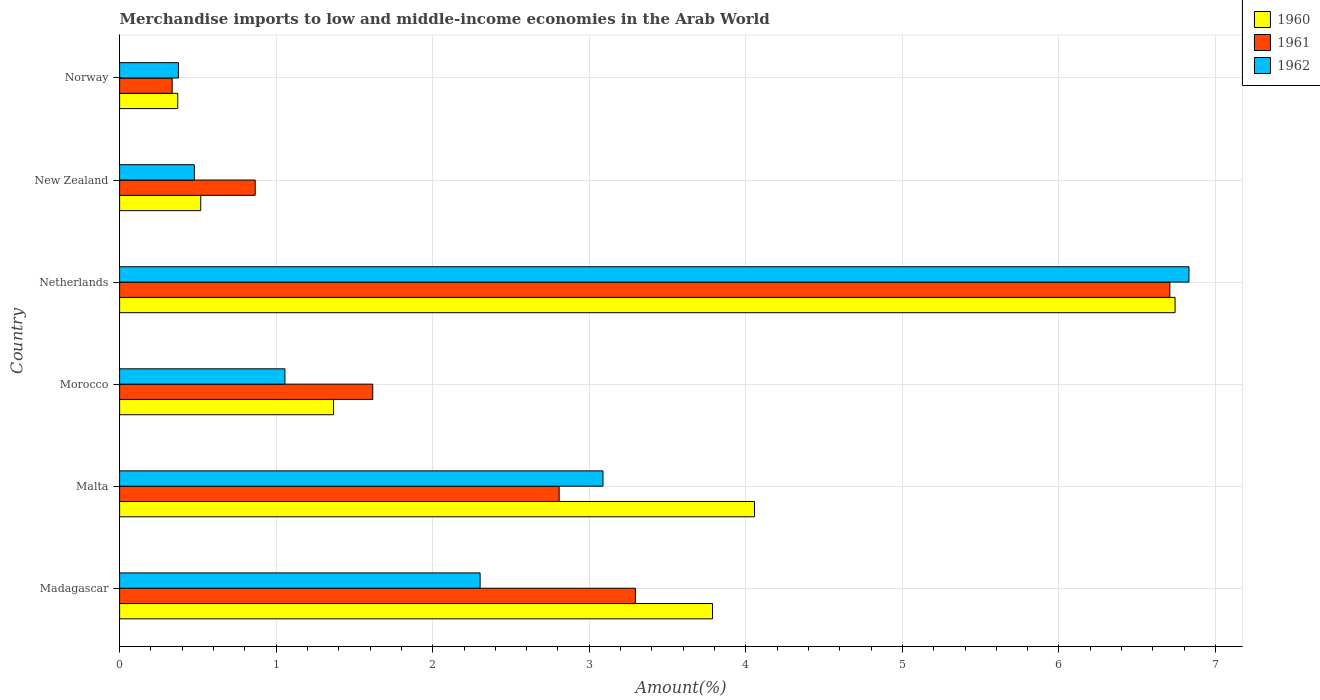Are the number of bars per tick equal to the number of legend labels?
Keep it short and to the point. Yes. How many bars are there on the 2nd tick from the top?
Provide a succinct answer. 3. What is the label of the 1st group of bars from the top?
Ensure brevity in your answer.  Norway. What is the percentage of amount earned from merchandise imports in 1961 in Morocco?
Keep it short and to the point. 1.62. Across all countries, what is the maximum percentage of amount earned from merchandise imports in 1960?
Your answer should be very brief. 6.74. Across all countries, what is the minimum percentage of amount earned from merchandise imports in 1960?
Offer a very short reply. 0.37. What is the total percentage of amount earned from merchandise imports in 1960 in the graph?
Your response must be concise. 16.84. What is the difference between the percentage of amount earned from merchandise imports in 1962 in Netherlands and that in New Zealand?
Your answer should be compact. 6.35. What is the difference between the percentage of amount earned from merchandise imports in 1962 in New Zealand and the percentage of amount earned from merchandise imports in 1960 in Madagascar?
Ensure brevity in your answer.  -3.31. What is the average percentage of amount earned from merchandise imports in 1961 per country?
Provide a succinct answer. 2.6. What is the difference between the percentage of amount earned from merchandise imports in 1961 and percentage of amount earned from merchandise imports in 1960 in Malta?
Offer a very short reply. -1.25. In how many countries, is the percentage of amount earned from merchandise imports in 1962 greater than 5.4 %?
Ensure brevity in your answer.  1. What is the ratio of the percentage of amount earned from merchandise imports in 1960 in Malta to that in Norway?
Keep it short and to the point. 10.92. Is the percentage of amount earned from merchandise imports in 1962 in Madagascar less than that in Norway?
Give a very brief answer. No. Is the difference between the percentage of amount earned from merchandise imports in 1961 in Madagascar and Netherlands greater than the difference between the percentage of amount earned from merchandise imports in 1960 in Madagascar and Netherlands?
Your answer should be very brief. No. What is the difference between the highest and the second highest percentage of amount earned from merchandise imports in 1961?
Keep it short and to the point. 3.41. What is the difference between the highest and the lowest percentage of amount earned from merchandise imports in 1960?
Make the answer very short. 6.37. In how many countries, is the percentage of amount earned from merchandise imports in 1962 greater than the average percentage of amount earned from merchandise imports in 1962 taken over all countries?
Keep it short and to the point. 2. What does the 2nd bar from the bottom in Malta represents?
Offer a very short reply. 1961. Is it the case that in every country, the sum of the percentage of amount earned from merchandise imports in 1962 and percentage of amount earned from merchandise imports in 1961 is greater than the percentage of amount earned from merchandise imports in 1960?
Provide a succinct answer. Yes. Does the graph contain any zero values?
Your response must be concise. No. How are the legend labels stacked?
Your answer should be very brief. Vertical. What is the title of the graph?
Provide a short and direct response. Merchandise imports to low and middle-income economies in the Arab World. What is the label or title of the X-axis?
Provide a succinct answer. Amount(%). What is the Amount(%) of 1960 in Madagascar?
Offer a very short reply. 3.79. What is the Amount(%) in 1961 in Madagascar?
Give a very brief answer. 3.29. What is the Amount(%) in 1962 in Madagascar?
Your answer should be very brief. 2.3. What is the Amount(%) in 1960 in Malta?
Give a very brief answer. 4.06. What is the Amount(%) in 1961 in Malta?
Keep it short and to the point. 2.81. What is the Amount(%) of 1962 in Malta?
Your answer should be very brief. 3.09. What is the Amount(%) of 1960 in Morocco?
Make the answer very short. 1.37. What is the Amount(%) in 1961 in Morocco?
Offer a terse response. 1.62. What is the Amount(%) in 1962 in Morocco?
Give a very brief answer. 1.06. What is the Amount(%) of 1960 in Netherlands?
Provide a short and direct response. 6.74. What is the Amount(%) of 1961 in Netherlands?
Give a very brief answer. 6.71. What is the Amount(%) of 1962 in Netherlands?
Keep it short and to the point. 6.83. What is the Amount(%) of 1960 in New Zealand?
Keep it short and to the point. 0.52. What is the Amount(%) in 1961 in New Zealand?
Offer a terse response. 0.87. What is the Amount(%) in 1962 in New Zealand?
Offer a terse response. 0.48. What is the Amount(%) in 1960 in Norway?
Ensure brevity in your answer.  0.37. What is the Amount(%) in 1961 in Norway?
Your response must be concise. 0.34. What is the Amount(%) of 1962 in Norway?
Your answer should be very brief. 0.38. Across all countries, what is the maximum Amount(%) of 1960?
Keep it short and to the point. 6.74. Across all countries, what is the maximum Amount(%) in 1961?
Keep it short and to the point. 6.71. Across all countries, what is the maximum Amount(%) of 1962?
Provide a short and direct response. 6.83. Across all countries, what is the minimum Amount(%) of 1960?
Your answer should be compact. 0.37. Across all countries, what is the minimum Amount(%) of 1961?
Provide a short and direct response. 0.34. Across all countries, what is the minimum Amount(%) in 1962?
Your response must be concise. 0.38. What is the total Amount(%) in 1960 in the graph?
Offer a terse response. 16.84. What is the total Amount(%) in 1961 in the graph?
Your answer should be compact. 15.63. What is the total Amount(%) in 1962 in the graph?
Provide a short and direct response. 14.13. What is the difference between the Amount(%) in 1960 in Madagascar and that in Malta?
Keep it short and to the point. -0.27. What is the difference between the Amount(%) of 1961 in Madagascar and that in Malta?
Offer a very short reply. 0.49. What is the difference between the Amount(%) in 1962 in Madagascar and that in Malta?
Provide a succinct answer. -0.79. What is the difference between the Amount(%) of 1960 in Madagascar and that in Morocco?
Provide a succinct answer. 2.42. What is the difference between the Amount(%) in 1961 in Madagascar and that in Morocco?
Make the answer very short. 1.68. What is the difference between the Amount(%) of 1962 in Madagascar and that in Morocco?
Provide a succinct answer. 1.25. What is the difference between the Amount(%) of 1960 in Madagascar and that in Netherlands?
Give a very brief answer. -2.95. What is the difference between the Amount(%) in 1961 in Madagascar and that in Netherlands?
Give a very brief answer. -3.41. What is the difference between the Amount(%) of 1962 in Madagascar and that in Netherlands?
Offer a very short reply. -4.53. What is the difference between the Amount(%) of 1960 in Madagascar and that in New Zealand?
Give a very brief answer. 3.27. What is the difference between the Amount(%) of 1961 in Madagascar and that in New Zealand?
Provide a succinct answer. 2.43. What is the difference between the Amount(%) in 1962 in Madagascar and that in New Zealand?
Offer a very short reply. 1.83. What is the difference between the Amount(%) in 1960 in Madagascar and that in Norway?
Provide a succinct answer. 3.42. What is the difference between the Amount(%) of 1961 in Madagascar and that in Norway?
Your answer should be compact. 2.96. What is the difference between the Amount(%) in 1962 in Madagascar and that in Norway?
Provide a succinct answer. 1.93. What is the difference between the Amount(%) of 1960 in Malta and that in Morocco?
Your response must be concise. 2.69. What is the difference between the Amount(%) in 1961 in Malta and that in Morocco?
Keep it short and to the point. 1.19. What is the difference between the Amount(%) of 1962 in Malta and that in Morocco?
Your answer should be very brief. 2.03. What is the difference between the Amount(%) of 1960 in Malta and that in Netherlands?
Ensure brevity in your answer.  -2.69. What is the difference between the Amount(%) in 1961 in Malta and that in Netherlands?
Offer a very short reply. -3.9. What is the difference between the Amount(%) of 1962 in Malta and that in Netherlands?
Give a very brief answer. -3.74. What is the difference between the Amount(%) of 1960 in Malta and that in New Zealand?
Make the answer very short. 3.54. What is the difference between the Amount(%) in 1961 in Malta and that in New Zealand?
Provide a short and direct response. 1.94. What is the difference between the Amount(%) of 1962 in Malta and that in New Zealand?
Provide a succinct answer. 2.61. What is the difference between the Amount(%) in 1960 in Malta and that in Norway?
Your response must be concise. 3.68. What is the difference between the Amount(%) of 1961 in Malta and that in Norway?
Offer a very short reply. 2.47. What is the difference between the Amount(%) in 1962 in Malta and that in Norway?
Your answer should be compact. 2.71. What is the difference between the Amount(%) of 1960 in Morocco and that in Netherlands?
Your answer should be compact. -5.38. What is the difference between the Amount(%) of 1961 in Morocco and that in Netherlands?
Give a very brief answer. -5.09. What is the difference between the Amount(%) of 1962 in Morocco and that in Netherlands?
Your answer should be very brief. -5.77. What is the difference between the Amount(%) in 1960 in Morocco and that in New Zealand?
Ensure brevity in your answer.  0.85. What is the difference between the Amount(%) in 1961 in Morocco and that in New Zealand?
Ensure brevity in your answer.  0.75. What is the difference between the Amount(%) in 1962 in Morocco and that in New Zealand?
Offer a very short reply. 0.58. What is the difference between the Amount(%) in 1960 in Morocco and that in Norway?
Your answer should be compact. 1. What is the difference between the Amount(%) in 1961 in Morocco and that in Norway?
Your response must be concise. 1.28. What is the difference between the Amount(%) of 1962 in Morocco and that in Norway?
Your answer should be compact. 0.68. What is the difference between the Amount(%) of 1960 in Netherlands and that in New Zealand?
Offer a very short reply. 6.22. What is the difference between the Amount(%) in 1961 in Netherlands and that in New Zealand?
Provide a short and direct response. 5.84. What is the difference between the Amount(%) of 1962 in Netherlands and that in New Zealand?
Provide a succinct answer. 6.35. What is the difference between the Amount(%) of 1960 in Netherlands and that in Norway?
Ensure brevity in your answer.  6.37. What is the difference between the Amount(%) in 1961 in Netherlands and that in Norway?
Your answer should be very brief. 6.37. What is the difference between the Amount(%) in 1962 in Netherlands and that in Norway?
Offer a terse response. 6.45. What is the difference between the Amount(%) in 1960 in New Zealand and that in Norway?
Keep it short and to the point. 0.15. What is the difference between the Amount(%) in 1961 in New Zealand and that in Norway?
Your answer should be compact. 0.53. What is the difference between the Amount(%) of 1962 in New Zealand and that in Norway?
Give a very brief answer. 0.1. What is the difference between the Amount(%) of 1960 in Madagascar and the Amount(%) of 1961 in Malta?
Your response must be concise. 0.98. What is the difference between the Amount(%) in 1960 in Madagascar and the Amount(%) in 1962 in Malta?
Keep it short and to the point. 0.7. What is the difference between the Amount(%) in 1961 in Madagascar and the Amount(%) in 1962 in Malta?
Provide a succinct answer. 0.21. What is the difference between the Amount(%) in 1960 in Madagascar and the Amount(%) in 1961 in Morocco?
Ensure brevity in your answer.  2.17. What is the difference between the Amount(%) of 1960 in Madagascar and the Amount(%) of 1962 in Morocco?
Ensure brevity in your answer.  2.73. What is the difference between the Amount(%) of 1961 in Madagascar and the Amount(%) of 1962 in Morocco?
Offer a terse response. 2.24. What is the difference between the Amount(%) of 1960 in Madagascar and the Amount(%) of 1961 in Netherlands?
Provide a succinct answer. -2.92. What is the difference between the Amount(%) of 1960 in Madagascar and the Amount(%) of 1962 in Netherlands?
Provide a succinct answer. -3.04. What is the difference between the Amount(%) of 1961 in Madagascar and the Amount(%) of 1962 in Netherlands?
Give a very brief answer. -3.54. What is the difference between the Amount(%) in 1960 in Madagascar and the Amount(%) in 1961 in New Zealand?
Give a very brief answer. 2.92. What is the difference between the Amount(%) in 1960 in Madagascar and the Amount(%) in 1962 in New Zealand?
Provide a short and direct response. 3.31. What is the difference between the Amount(%) of 1961 in Madagascar and the Amount(%) of 1962 in New Zealand?
Ensure brevity in your answer.  2.82. What is the difference between the Amount(%) of 1960 in Madagascar and the Amount(%) of 1961 in Norway?
Keep it short and to the point. 3.45. What is the difference between the Amount(%) of 1960 in Madagascar and the Amount(%) of 1962 in Norway?
Offer a very short reply. 3.41. What is the difference between the Amount(%) in 1961 in Madagascar and the Amount(%) in 1962 in Norway?
Offer a very short reply. 2.92. What is the difference between the Amount(%) of 1960 in Malta and the Amount(%) of 1961 in Morocco?
Your response must be concise. 2.44. What is the difference between the Amount(%) in 1960 in Malta and the Amount(%) in 1962 in Morocco?
Provide a succinct answer. 3. What is the difference between the Amount(%) in 1961 in Malta and the Amount(%) in 1962 in Morocco?
Your response must be concise. 1.75. What is the difference between the Amount(%) in 1960 in Malta and the Amount(%) in 1961 in Netherlands?
Offer a very short reply. -2.65. What is the difference between the Amount(%) in 1960 in Malta and the Amount(%) in 1962 in Netherlands?
Offer a terse response. -2.77. What is the difference between the Amount(%) in 1961 in Malta and the Amount(%) in 1962 in Netherlands?
Your answer should be very brief. -4.02. What is the difference between the Amount(%) in 1960 in Malta and the Amount(%) in 1961 in New Zealand?
Keep it short and to the point. 3.19. What is the difference between the Amount(%) in 1960 in Malta and the Amount(%) in 1962 in New Zealand?
Offer a terse response. 3.58. What is the difference between the Amount(%) in 1961 in Malta and the Amount(%) in 1962 in New Zealand?
Provide a short and direct response. 2.33. What is the difference between the Amount(%) in 1960 in Malta and the Amount(%) in 1961 in Norway?
Keep it short and to the point. 3.72. What is the difference between the Amount(%) in 1960 in Malta and the Amount(%) in 1962 in Norway?
Your answer should be compact. 3.68. What is the difference between the Amount(%) in 1961 in Malta and the Amount(%) in 1962 in Norway?
Keep it short and to the point. 2.43. What is the difference between the Amount(%) of 1960 in Morocco and the Amount(%) of 1961 in Netherlands?
Offer a very short reply. -5.34. What is the difference between the Amount(%) of 1960 in Morocco and the Amount(%) of 1962 in Netherlands?
Your answer should be compact. -5.46. What is the difference between the Amount(%) in 1961 in Morocco and the Amount(%) in 1962 in Netherlands?
Offer a very short reply. -5.21. What is the difference between the Amount(%) of 1960 in Morocco and the Amount(%) of 1961 in New Zealand?
Offer a terse response. 0.5. What is the difference between the Amount(%) of 1960 in Morocco and the Amount(%) of 1962 in New Zealand?
Provide a succinct answer. 0.89. What is the difference between the Amount(%) of 1961 in Morocco and the Amount(%) of 1962 in New Zealand?
Your response must be concise. 1.14. What is the difference between the Amount(%) of 1960 in Morocco and the Amount(%) of 1961 in Norway?
Provide a short and direct response. 1.03. What is the difference between the Amount(%) of 1960 in Morocco and the Amount(%) of 1962 in Norway?
Keep it short and to the point. 0.99. What is the difference between the Amount(%) in 1961 in Morocco and the Amount(%) in 1962 in Norway?
Provide a short and direct response. 1.24. What is the difference between the Amount(%) of 1960 in Netherlands and the Amount(%) of 1961 in New Zealand?
Make the answer very short. 5.88. What is the difference between the Amount(%) in 1960 in Netherlands and the Amount(%) in 1962 in New Zealand?
Offer a terse response. 6.26. What is the difference between the Amount(%) of 1961 in Netherlands and the Amount(%) of 1962 in New Zealand?
Give a very brief answer. 6.23. What is the difference between the Amount(%) of 1960 in Netherlands and the Amount(%) of 1961 in Norway?
Make the answer very short. 6.41. What is the difference between the Amount(%) in 1960 in Netherlands and the Amount(%) in 1962 in Norway?
Your response must be concise. 6.37. What is the difference between the Amount(%) in 1961 in Netherlands and the Amount(%) in 1962 in Norway?
Your answer should be compact. 6.33. What is the difference between the Amount(%) in 1960 in New Zealand and the Amount(%) in 1961 in Norway?
Offer a terse response. 0.18. What is the difference between the Amount(%) of 1960 in New Zealand and the Amount(%) of 1962 in Norway?
Your answer should be very brief. 0.14. What is the difference between the Amount(%) of 1961 in New Zealand and the Amount(%) of 1962 in Norway?
Offer a very short reply. 0.49. What is the average Amount(%) in 1960 per country?
Provide a succinct answer. 2.81. What is the average Amount(%) in 1961 per country?
Provide a succinct answer. 2.6. What is the average Amount(%) of 1962 per country?
Ensure brevity in your answer.  2.35. What is the difference between the Amount(%) of 1960 and Amount(%) of 1961 in Madagascar?
Provide a succinct answer. 0.49. What is the difference between the Amount(%) of 1960 and Amount(%) of 1962 in Madagascar?
Ensure brevity in your answer.  1.48. What is the difference between the Amount(%) in 1960 and Amount(%) in 1961 in Malta?
Keep it short and to the point. 1.25. What is the difference between the Amount(%) in 1960 and Amount(%) in 1962 in Malta?
Your answer should be compact. 0.97. What is the difference between the Amount(%) in 1961 and Amount(%) in 1962 in Malta?
Ensure brevity in your answer.  -0.28. What is the difference between the Amount(%) of 1960 and Amount(%) of 1961 in Morocco?
Your response must be concise. -0.25. What is the difference between the Amount(%) of 1960 and Amount(%) of 1962 in Morocco?
Offer a very short reply. 0.31. What is the difference between the Amount(%) of 1961 and Amount(%) of 1962 in Morocco?
Your answer should be compact. 0.56. What is the difference between the Amount(%) of 1960 and Amount(%) of 1961 in Netherlands?
Provide a succinct answer. 0.03. What is the difference between the Amount(%) in 1960 and Amount(%) in 1962 in Netherlands?
Provide a short and direct response. -0.09. What is the difference between the Amount(%) in 1961 and Amount(%) in 1962 in Netherlands?
Provide a succinct answer. -0.12. What is the difference between the Amount(%) of 1960 and Amount(%) of 1961 in New Zealand?
Keep it short and to the point. -0.35. What is the difference between the Amount(%) of 1960 and Amount(%) of 1962 in New Zealand?
Provide a short and direct response. 0.04. What is the difference between the Amount(%) of 1961 and Amount(%) of 1962 in New Zealand?
Provide a succinct answer. 0.39. What is the difference between the Amount(%) of 1960 and Amount(%) of 1961 in Norway?
Your response must be concise. 0.04. What is the difference between the Amount(%) in 1960 and Amount(%) in 1962 in Norway?
Provide a short and direct response. -0. What is the difference between the Amount(%) of 1961 and Amount(%) of 1962 in Norway?
Provide a short and direct response. -0.04. What is the ratio of the Amount(%) of 1960 in Madagascar to that in Malta?
Keep it short and to the point. 0.93. What is the ratio of the Amount(%) in 1961 in Madagascar to that in Malta?
Provide a short and direct response. 1.17. What is the ratio of the Amount(%) in 1962 in Madagascar to that in Malta?
Ensure brevity in your answer.  0.75. What is the ratio of the Amount(%) in 1960 in Madagascar to that in Morocco?
Your answer should be compact. 2.77. What is the ratio of the Amount(%) in 1961 in Madagascar to that in Morocco?
Keep it short and to the point. 2.04. What is the ratio of the Amount(%) in 1962 in Madagascar to that in Morocco?
Provide a succinct answer. 2.18. What is the ratio of the Amount(%) in 1960 in Madagascar to that in Netherlands?
Your answer should be very brief. 0.56. What is the ratio of the Amount(%) of 1961 in Madagascar to that in Netherlands?
Your response must be concise. 0.49. What is the ratio of the Amount(%) of 1962 in Madagascar to that in Netherlands?
Your answer should be very brief. 0.34. What is the ratio of the Amount(%) in 1960 in Madagascar to that in New Zealand?
Offer a very short reply. 7.31. What is the ratio of the Amount(%) in 1961 in Madagascar to that in New Zealand?
Provide a succinct answer. 3.8. What is the ratio of the Amount(%) of 1962 in Madagascar to that in New Zealand?
Your response must be concise. 4.82. What is the ratio of the Amount(%) in 1960 in Madagascar to that in Norway?
Provide a succinct answer. 10.2. What is the ratio of the Amount(%) of 1961 in Madagascar to that in Norway?
Your answer should be very brief. 9.81. What is the ratio of the Amount(%) in 1962 in Madagascar to that in Norway?
Keep it short and to the point. 6.13. What is the ratio of the Amount(%) of 1960 in Malta to that in Morocco?
Ensure brevity in your answer.  2.97. What is the ratio of the Amount(%) in 1961 in Malta to that in Morocco?
Ensure brevity in your answer.  1.74. What is the ratio of the Amount(%) of 1962 in Malta to that in Morocco?
Ensure brevity in your answer.  2.92. What is the ratio of the Amount(%) of 1960 in Malta to that in Netherlands?
Your response must be concise. 0.6. What is the ratio of the Amount(%) of 1961 in Malta to that in Netherlands?
Offer a very short reply. 0.42. What is the ratio of the Amount(%) of 1962 in Malta to that in Netherlands?
Your answer should be compact. 0.45. What is the ratio of the Amount(%) in 1960 in Malta to that in New Zealand?
Make the answer very short. 7.83. What is the ratio of the Amount(%) of 1961 in Malta to that in New Zealand?
Your answer should be very brief. 3.24. What is the ratio of the Amount(%) in 1962 in Malta to that in New Zealand?
Your response must be concise. 6.47. What is the ratio of the Amount(%) in 1960 in Malta to that in Norway?
Ensure brevity in your answer.  10.92. What is the ratio of the Amount(%) of 1961 in Malta to that in Norway?
Your answer should be compact. 8.36. What is the ratio of the Amount(%) of 1962 in Malta to that in Norway?
Make the answer very short. 8.22. What is the ratio of the Amount(%) of 1960 in Morocco to that in Netherlands?
Ensure brevity in your answer.  0.2. What is the ratio of the Amount(%) in 1961 in Morocco to that in Netherlands?
Your answer should be compact. 0.24. What is the ratio of the Amount(%) in 1962 in Morocco to that in Netherlands?
Your response must be concise. 0.15. What is the ratio of the Amount(%) in 1960 in Morocco to that in New Zealand?
Keep it short and to the point. 2.64. What is the ratio of the Amount(%) of 1961 in Morocco to that in New Zealand?
Your answer should be compact. 1.87. What is the ratio of the Amount(%) of 1962 in Morocco to that in New Zealand?
Keep it short and to the point. 2.21. What is the ratio of the Amount(%) of 1960 in Morocco to that in Norway?
Offer a terse response. 3.68. What is the ratio of the Amount(%) in 1961 in Morocco to that in Norway?
Provide a succinct answer. 4.82. What is the ratio of the Amount(%) of 1962 in Morocco to that in Norway?
Provide a short and direct response. 2.81. What is the ratio of the Amount(%) in 1960 in Netherlands to that in New Zealand?
Give a very brief answer. 13.01. What is the ratio of the Amount(%) in 1961 in Netherlands to that in New Zealand?
Ensure brevity in your answer.  7.75. What is the ratio of the Amount(%) of 1962 in Netherlands to that in New Zealand?
Your answer should be compact. 14.3. What is the ratio of the Amount(%) in 1960 in Netherlands to that in Norway?
Ensure brevity in your answer.  18.15. What is the ratio of the Amount(%) in 1961 in Netherlands to that in Norway?
Your answer should be compact. 19.98. What is the ratio of the Amount(%) of 1962 in Netherlands to that in Norway?
Your answer should be very brief. 18.18. What is the ratio of the Amount(%) of 1960 in New Zealand to that in Norway?
Your answer should be compact. 1.4. What is the ratio of the Amount(%) in 1961 in New Zealand to that in Norway?
Give a very brief answer. 2.58. What is the ratio of the Amount(%) of 1962 in New Zealand to that in Norway?
Keep it short and to the point. 1.27. What is the difference between the highest and the second highest Amount(%) in 1960?
Keep it short and to the point. 2.69. What is the difference between the highest and the second highest Amount(%) of 1961?
Provide a succinct answer. 3.41. What is the difference between the highest and the second highest Amount(%) of 1962?
Make the answer very short. 3.74. What is the difference between the highest and the lowest Amount(%) of 1960?
Provide a short and direct response. 6.37. What is the difference between the highest and the lowest Amount(%) in 1961?
Your answer should be very brief. 6.37. What is the difference between the highest and the lowest Amount(%) in 1962?
Keep it short and to the point. 6.45. 